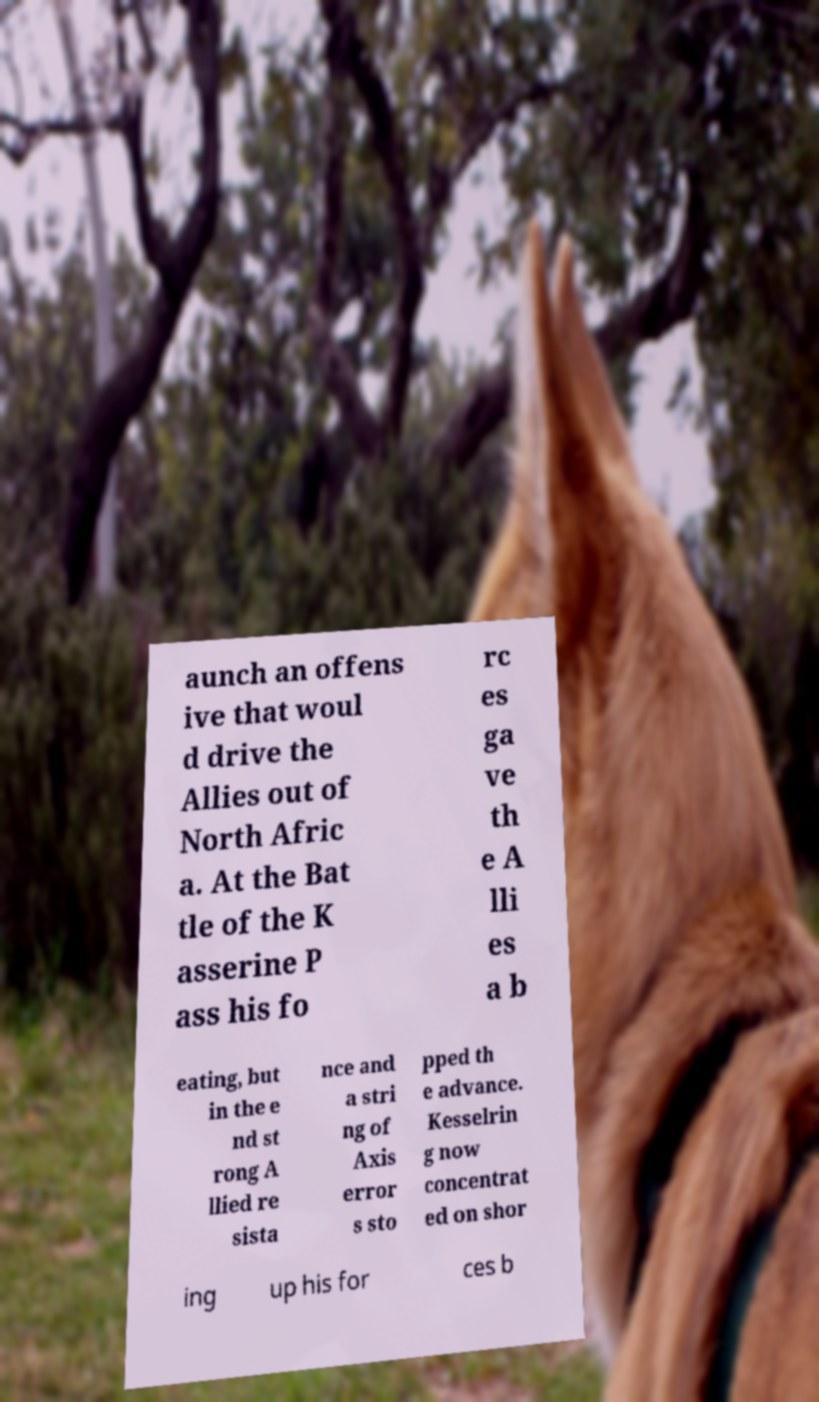Could you assist in decoding the text presented in this image and type it out clearly? aunch an offens ive that woul d drive the Allies out of North Afric a. At the Bat tle of the K asserine P ass his fo rc es ga ve th e A lli es a b eating, but in the e nd st rong A llied re sista nce and a stri ng of Axis error s sto pped th e advance. Kesselrin g now concentrat ed on shor ing up his for ces b 